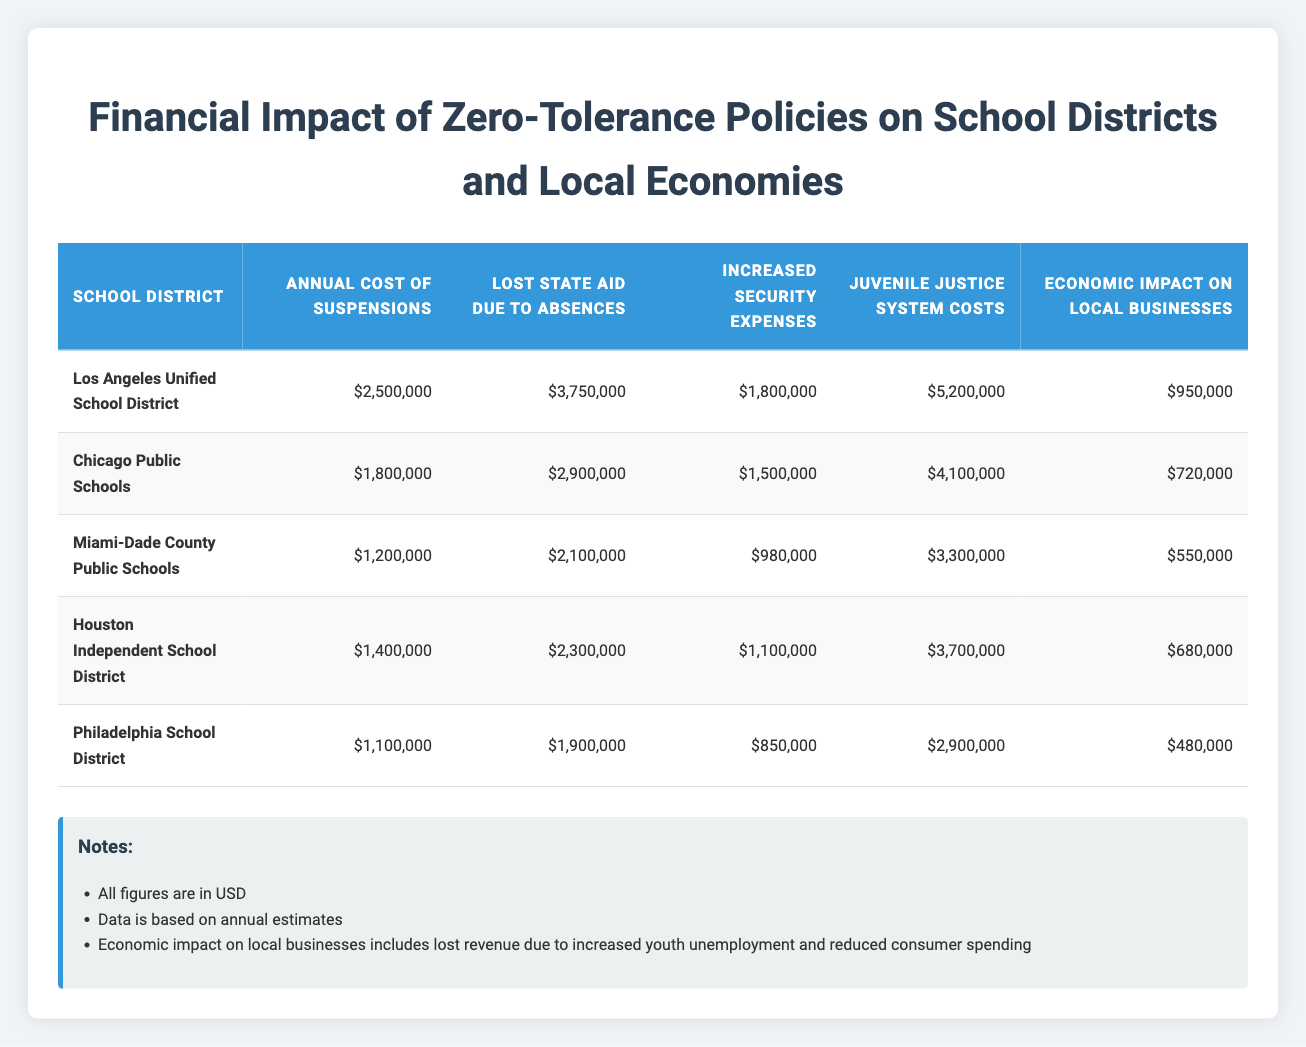What is the annual cost of suspensions in the Los Angeles Unified School District? The table states that the annual cost of suspensions for the Los Angeles Unified School District is listed in the corresponding row under the "Annual Cost of Suspensions" column. That value is 2,500,000.
Answer: 2,500,000 Which school district has the highest lost state aid due to absences? By comparing the values in the "Lost State Aid Due to Absences" column, the highest value is 3,750,000, which corresponds to the Los Angeles Unified School District.
Answer: Los Angeles Unified School District What is the total juvenile justice system costs for all districts combined? To find the total, sum the juvenile justice costs: 5,200,000 + 4,100,000 + 3,300,000 + 3,700,000 + 2,900,000 = 19,200,000.
Answer: 19,200,000 Is the economic impact on local businesses in Miami-Dade County Public Schools greater than 600,000? By looking at the "Economic Impact on Local Businesses" column, the value for Miami-Dade County Public Schools is 550,000, which is less than 600,000. So, the statement is false.
Answer: No What is the difference in annual costs of suspensions between the Chicago Public Schools and Philadelphia School District? The annual cost for Chicago Public Schools is 1,800,000, and for Philadelphia School District, it is 1,100,000. To find the difference, subtract: 1,800,000 - 1,100,000 = 700,000.
Answer: 700,000 What is the average annual cost of suspensions across all districts? Add the annual costs of suspensions: 2,500,000 + 1,800,000 + 1,200,000 + 1,400,000 + 1,100,000 = 8,000,000. There are 5 districts, so the average is 8,000,000 / 5 = 1,600,000.
Answer: 1,600,000 Which district has the lowest increased security expenses? Looking at the "Increased Security Expenses" column, the lowest value is 850,000, which corresponds to the Philadelphia School District.
Answer: Philadelphia School District What percentage of the economic impact on local businesses does the Los Angeles Unified School District represent compared to the total economic impact of all districts? First, sum the economic impacts: 950,000 + 720,000 + 550,000 + 680,000 + 480,000 = 3,380,000. Then, for Los Angeles Unified, the impact is 950,000. The percentage is (950,000 / 3,380,000) * 100 ≈ 28.09%.
Answer: Approximately 28.09% 